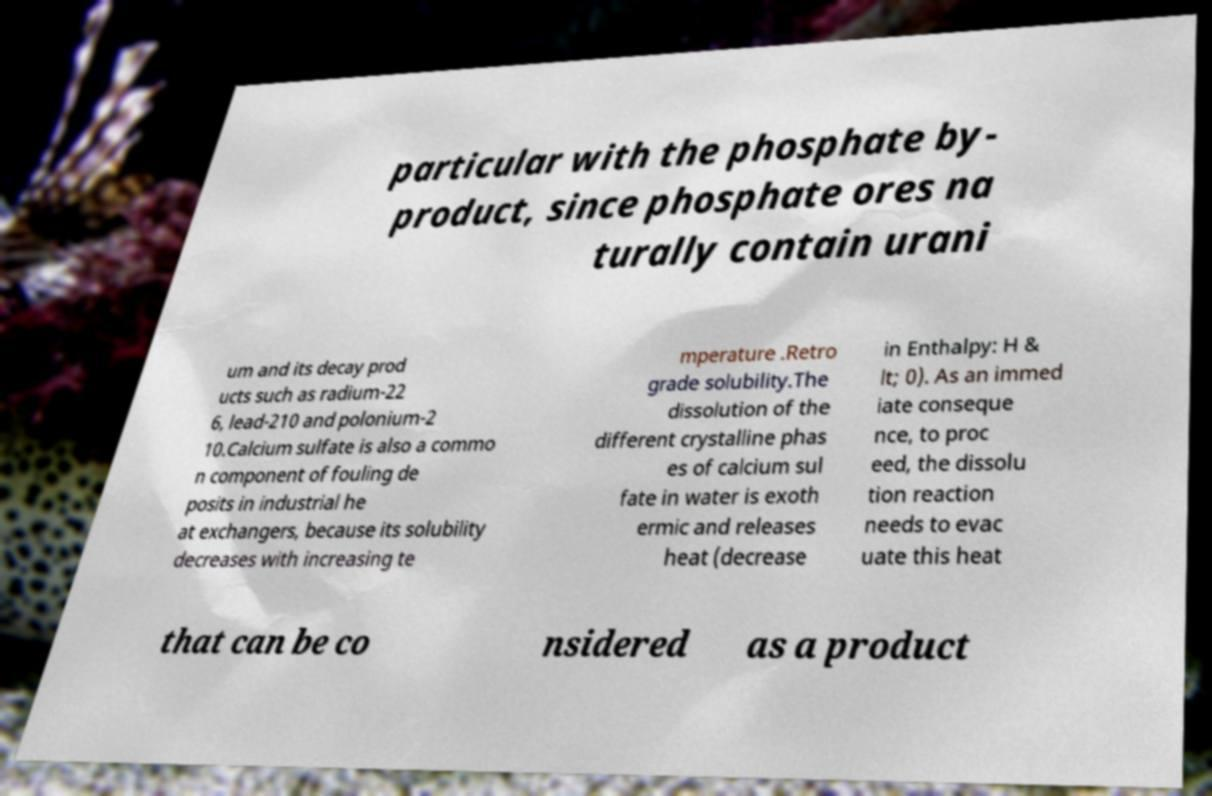I need the written content from this picture converted into text. Can you do that? particular with the phosphate by- product, since phosphate ores na turally contain urani um and its decay prod ucts such as radium-22 6, lead-210 and polonium-2 10.Calcium sulfate is also a commo n component of fouling de posits in industrial he at exchangers, because its solubility decreases with increasing te mperature .Retro grade solubility.The dissolution of the different crystalline phas es of calcium sul fate in water is exoth ermic and releases heat (decrease in Enthalpy: H & lt; 0). As an immed iate conseque nce, to proc eed, the dissolu tion reaction needs to evac uate this heat that can be co nsidered as a product 